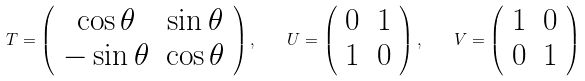Convert formula to latex. <formula><loc_0><loc_0><loc_500><loc_500>T = \left ( \begin{array} { c c } \cos { \theta } & \sin { \theta } \\ - \sin { \theta } & \cos { \theta } \end{array} \right ) , \quad U = \left ( \begin{array} { c c } 0 & 1 \\ 1 & 0 \end{array} \right ) , \quad V = \left ( \begin{array} { c c } 1 & 0 \\ 0 & 1 \end{array} \right )</formula> 